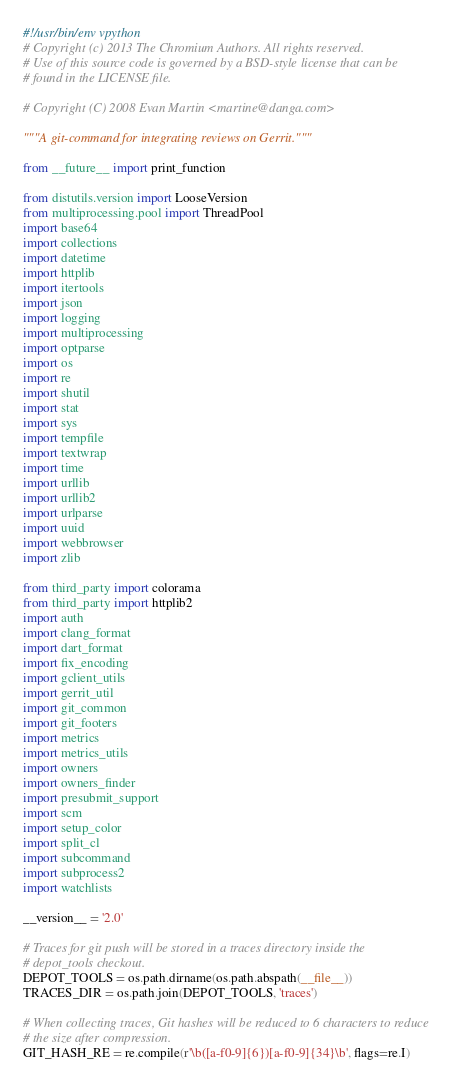Convert code to text. <code><loc_0><loc_0><loc_500><loc_500><_Python_>#!/usr/bin/env vpython
# Copyright (c) 2013 The Chromium Authors. All rights reserved.
# Use of this source code is governed by a BSD-style license that can be
# found in the LICENSE file.

# Copyright (C) 2008 Evan Martin <martine@danga.com>

"""A git-command for integrating reviews on Gerrit."""

from __future__ import print_function

from distutils.version import LooseVersion
from multiprocessing.pool import ThreadPool
import base64
import collections
import datetime
import httplib
import itertools
import json
import logging
import multiprocessing
import optparse
import os
import re
import shutil
import stat
import sys
import tempfile
import textwrap
import time
import urllib
import urllib2
import urlparse
import uuid
import webbrowser
import zlib

from third_party import colorama
from third_party import httplib2
import auth
import clang_format
import dart_format
import fix_encoding
import gclient_utils
import gerrit_util
import git_common
import git_footers
import metrics
import metrics_utils
import owners
import owners_finder
import presubmit_support
import scm
import setup_color
import split_cl
import subcommand
import subprocess2
import watchlists

__version__ = '2.0'

# Traces for git push will be stored in a traces directory inside the
# depot_tools checkout.
DEPOT_TOOLS = os.path.dirname(os.path.abspath(__file__))
TRACES_DIR = os.path.join(DEPOT_TOOLS, 'traces')

# When collecting traces, Git hashes will be reduced to 6 characters to reduce
# the size after compression.
GIT_HASH_RE = re.compile(r'\b([a-f0-9]{6})[a-f0-9]{34}\b', flags=re.I)</code> 